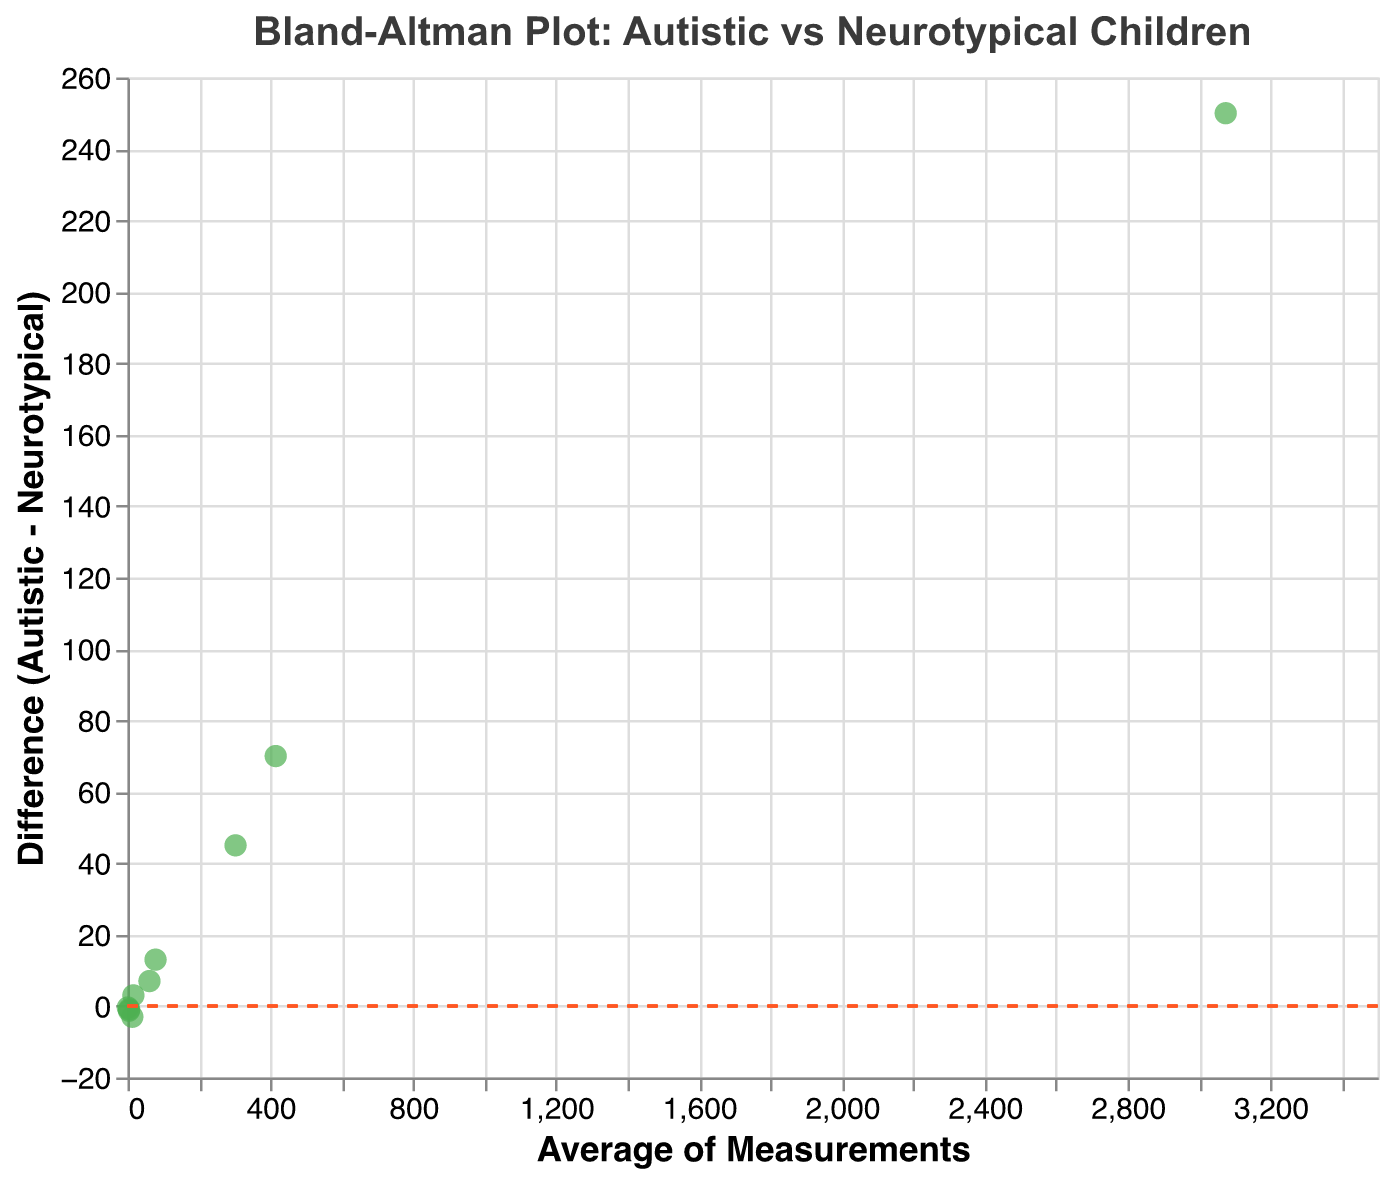What's the title of the figure? The figure's title can be found at the top and usually describes what the figure is about. In this case, it's "Bland-Altman Plot: Autistic vs Neurotypical Children".
Answer: Bland-Altman Plot: Autistic vs Neurotypical Children How many data points are plotted in the figure? Count the number of green points in the plot, which represent each data measurement. There are 10 measurements listed in the data, so there should be 10 points.
Answer: 10 What does the x-axis represent in this plot? The x-axis title can be found below the axis. It represents the "Average of Measurements", calculated as the mean of values from autistic and neurotypical children.
Answer: Average of Measurements What does the y-axis represent in this plot? The y-axis title can be found to the left of the axis. It represents the "Difference (Autistic - Neurotypical)", which is the difference between the values of autistic and neurotypical children for each measurement.
Answer: Difference (Autistic - Neurotypical) What does the dashed horizontal line at y=0 signify? In a Bland-Altman plot, the dashed line at y=0 indicates the line of equality, where there is no difference between the measurements of autistic and neurotypical children.
Answer: Line of equality Which measurement has the biggest positive difference? Identify the data point that is furthest above the horizontal y=0 line. This can be seen as the highest point on the y-axis. In this case, “Time to first fixation (ms)” is the highest at a difference of 70.
Answer: Time to first fixation (ms) Which measurement has the biggest negative difference? Identify the data point that is furthest below the horizontal y=0 line. This can be seen as the lowest point on the y-axis. In this case, “Gaze transition frequency” is the lowest at a difference of -0.4.
Answer: Gaze transition frequency What is the average difference between autistic and neurotypical children’s fixation duration? The fixation duration data point on the plot can be used to find this. The difference is 325 - 280 = 45 ms, and the average of the two values is (325 + 280) / 2 = 302.5 ms.
Answer: 45 ms Are there any measurements where the difference between the two groups is exactly zero? Look for any points where the y-value is exactly zero. Since the points do not lie on the y=0 dashed line in this figure, none of the measurements have a difference of zero.
Answer: No Do autistic children have longer average task completion times than neurotypical children? The difference for "Task completion time (s)" can be observed on the plot. The point for this measurement is above the y=0 line (difference is 7), indicating that autistic children have longer task completion times than neurotypical children.
Answer: Yes 